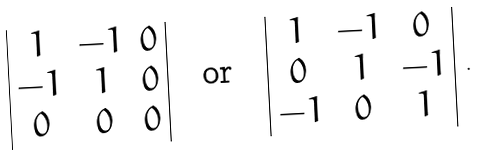<formula> <loc_0><loc_0><loc_500><loc_500>\begin{array} { | c c c | } 1 & - 1 & 0 \\ - 1 & 1 & 0 \\ 0 & 0 & 0 \\ \end{array} \quad \text {or} \quad \begin{array} { | c c c | } 1 & - 1 & 0 \\ 0 & 1 & - 1 \\ - 1 & 0 & 1 \\ \end{array} \ .</formula> 